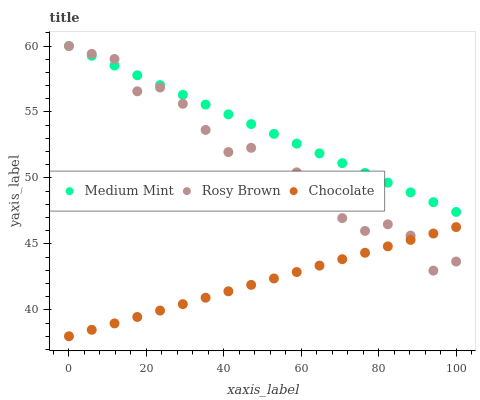Does Chocolate have the minimum area under the curve?
Answer yes or no. Yes. Does Medium Mint have the maximum area under the curve?
Answer yes or no. Yes. Does Rosy Brown have the minimum area under the curve?
Answer yes or no. No. Does Rosy Brown have the maximum area under the curve?
Answer yes or no. No. Is Medium Mint the smoothest?
Answer yes or no. Yes. Is Rosy Brown the roughest?
Answer yes or no. Yes. Is Chocolate the smoothest?
Answer yes or no. No. Is Chocolate the roughest?
Answer yes or no. No. Does Chocolate have the lowest value?
Answer yes or no. Yes. Does Rosy Brown have the lowest value?
Answer yes or no. No. Does Rosy Brown have the highest value?
Answer yes or no. Yes. Does Chocolate have the highest value?
Answer yes or no. No. Is Chocolate less than Medium Mint?
Answer yes or no. Yes. Is Medium Mint greater than Chocolate?
Answer yes or no. Yes. Does Chocolate intersect Rosy Brown?
Answer yes or no. Yes. Is Chocolate less than Rosy Brown?
Answer yes or no. No. Is Chocolate greater than Rosy Brown?
Answer yes or no. No. Does Chocolate intersect Medium Mint?
Answer yes or no. No. 